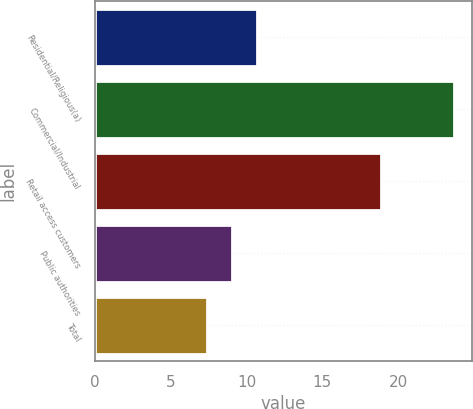Convert chart. <chart><loc_0><loc_0><loc_500><loc_500><bar_chart><fcel>Residential/Religious(a)<fcel>Commercial/Industrial<fcel>Retail access customers<fcel>Public authorities<fcel>Total<nl><fcel>10.66<fcel>23.7<fcel>18.9<fcel>9.03<fcel>7.4<nl></chart> 